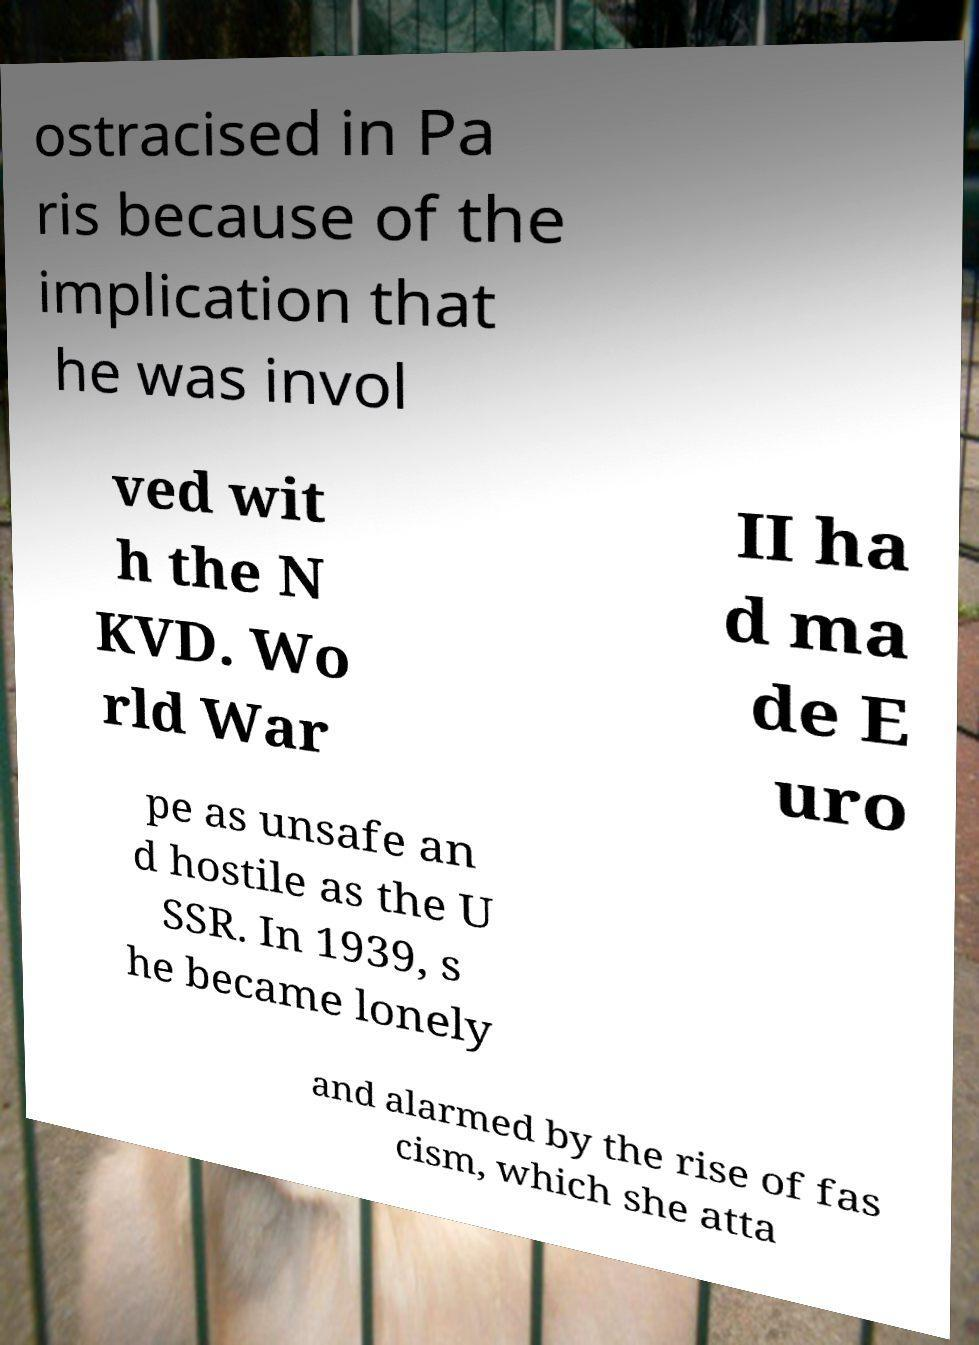Please identify and transcribe the text found in this image. ostracised in Pa ris because of the implication that he was invol ved wit h the N KVD. Wo rld War II ha d ma de E uro pe as unsafe an d hostile as the U SSR. In 1939, s he became lonely and alarmed by the rise of fas cism, which she atta 